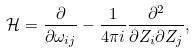Convert formula to latex. <formula><loc_0><loc_0><loc_500><loc_500>\mathcal { H } = \frac { \partial } { \partial \omega _ { i j } } - \frac { 1 } { 4 \pi i } \frac { \partial ^ { 2 } } { \partial Z _ { i } \partial Z _ { j } } ,</formula> 